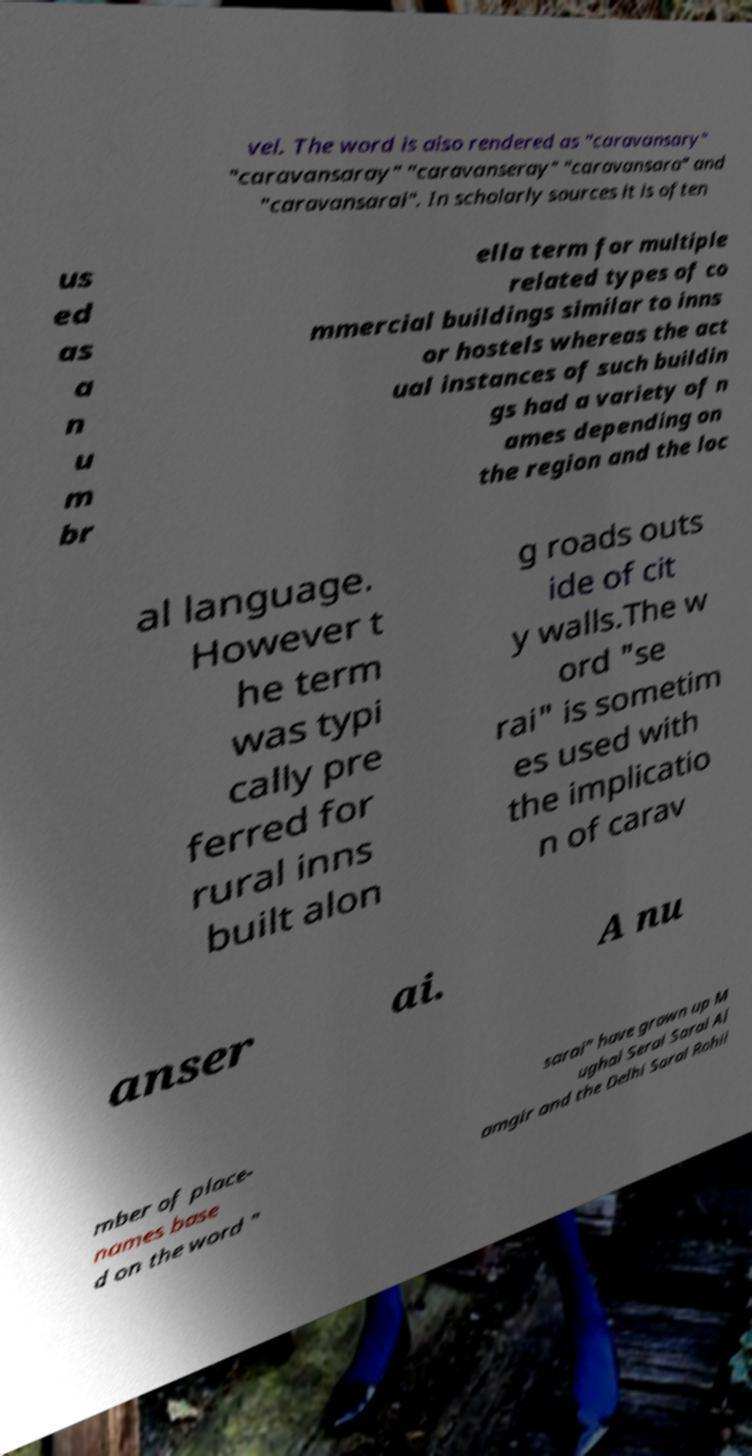For documentation purposes, I need the text within this image transcribed. Could you provide that? vel. The word is also rendered as "caravansary" "caravansaray" "caravanseray" "caravansara" and "caravansarai". In scholarly sources it is often us ed as a n u m br ella term for multiple related types of co mmercial buildings similar to inns or hostels whereas the act ual instances of such buildin gs had a variety of n ames depending on the region and the loc al language. However t he term was typi cally pre ferred for rural inns built alon g roads outs ide of cit y walls.The w ord "se rai" is sometim es used with the implicatio n of carav anser ai. A nu mber of place- names base d on the word " sarai" have grown up M ughal Serai Sarai Al amgir and the Delhi Sarai Rohil 